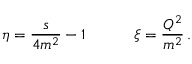Convert formula to latex. <formula><loc_0><loc_0><loc_500><loc_500>\eta = \frac { s } { 4 m ^ { 2 } } - 1 \quad \xi = \frac { Q ^ { 2 } } { m ^ { 2 } } \, .</formula> 